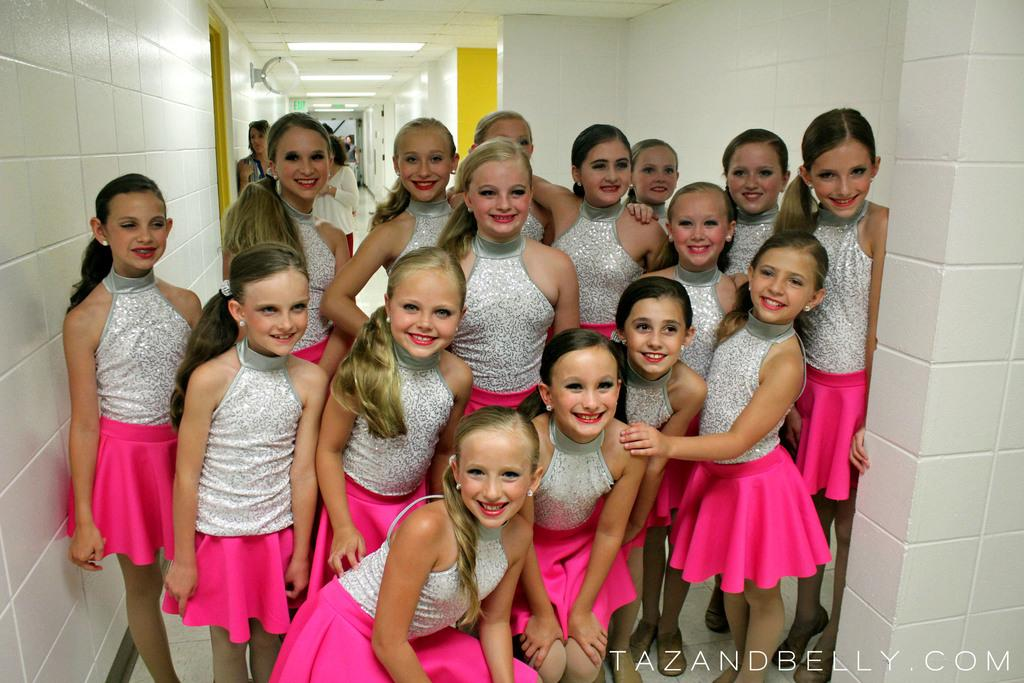What is the main subject of the image? The main subject of the image is a group of girls. What are the girls doing in the image? The girls are standing on the floor and smiling. What can be seen in the background of the image? In the background of the image, there are people, lights, walls, and objects. What type of letters are being exchanged between the girls in the image? There is no indication in the image that the girls are exchanging letters, so it cannot be determined from the picture. 